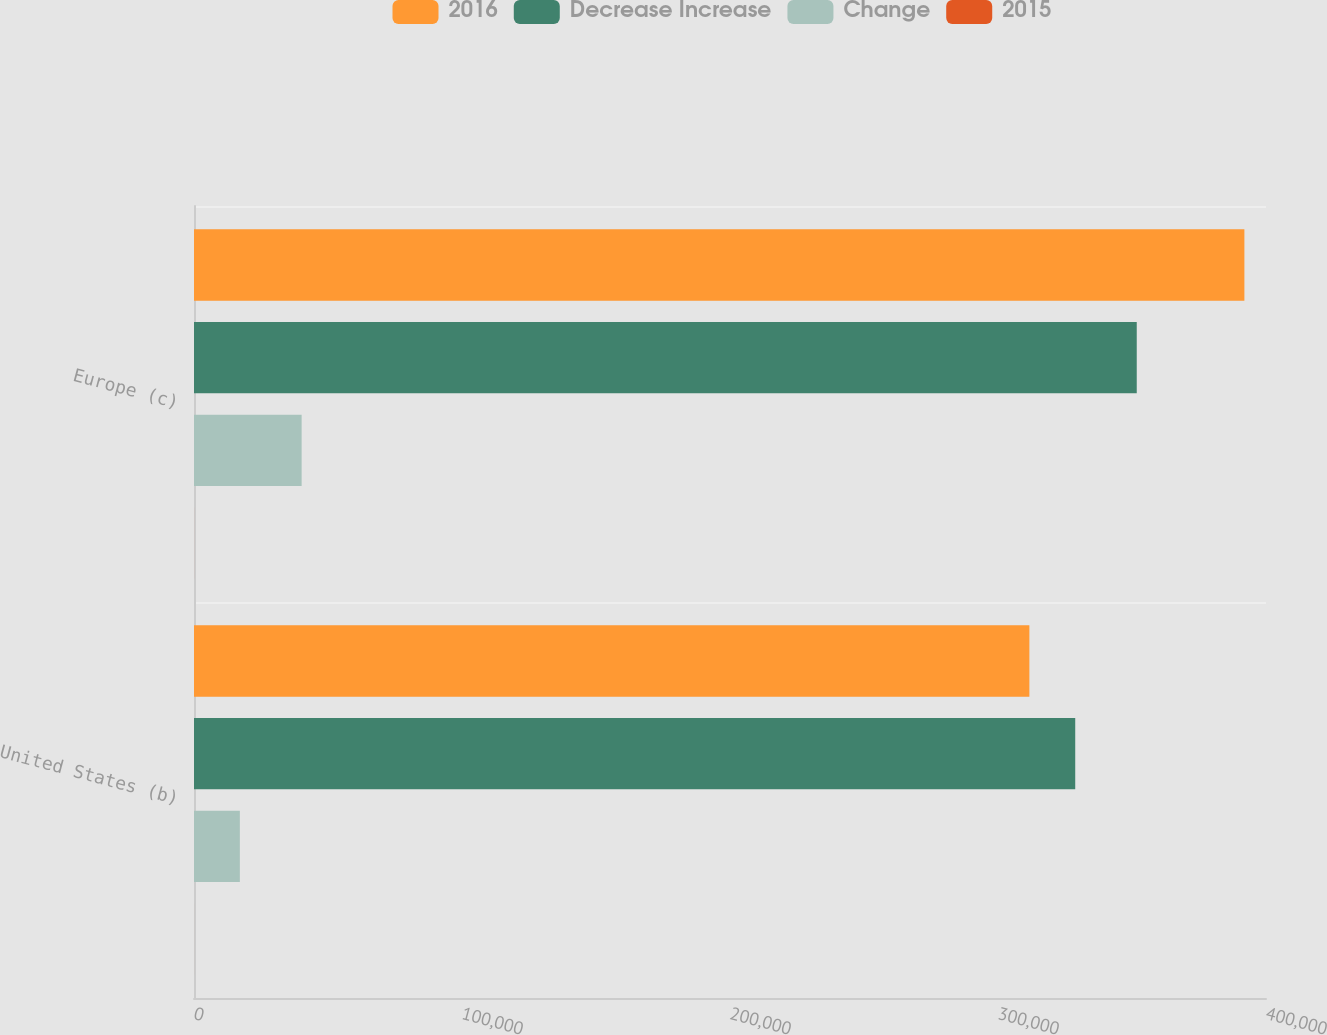Convert chart. <chart><loc_0><loc_0><loc_500><loc_500><stacked_bar_chart><ecel><fcel>United States (b)<fcel>Europe (c)<nl><fcel>2016<fcel>311710<fcel>391936<nl><fcel>Decrease Increase<fcel>328818<fcel>351773<nl><fcel>Change<fcel>17108<fcel>40163<nl><fcel>2015<fcel>5.2<fcel>11.4<nl></chart> 